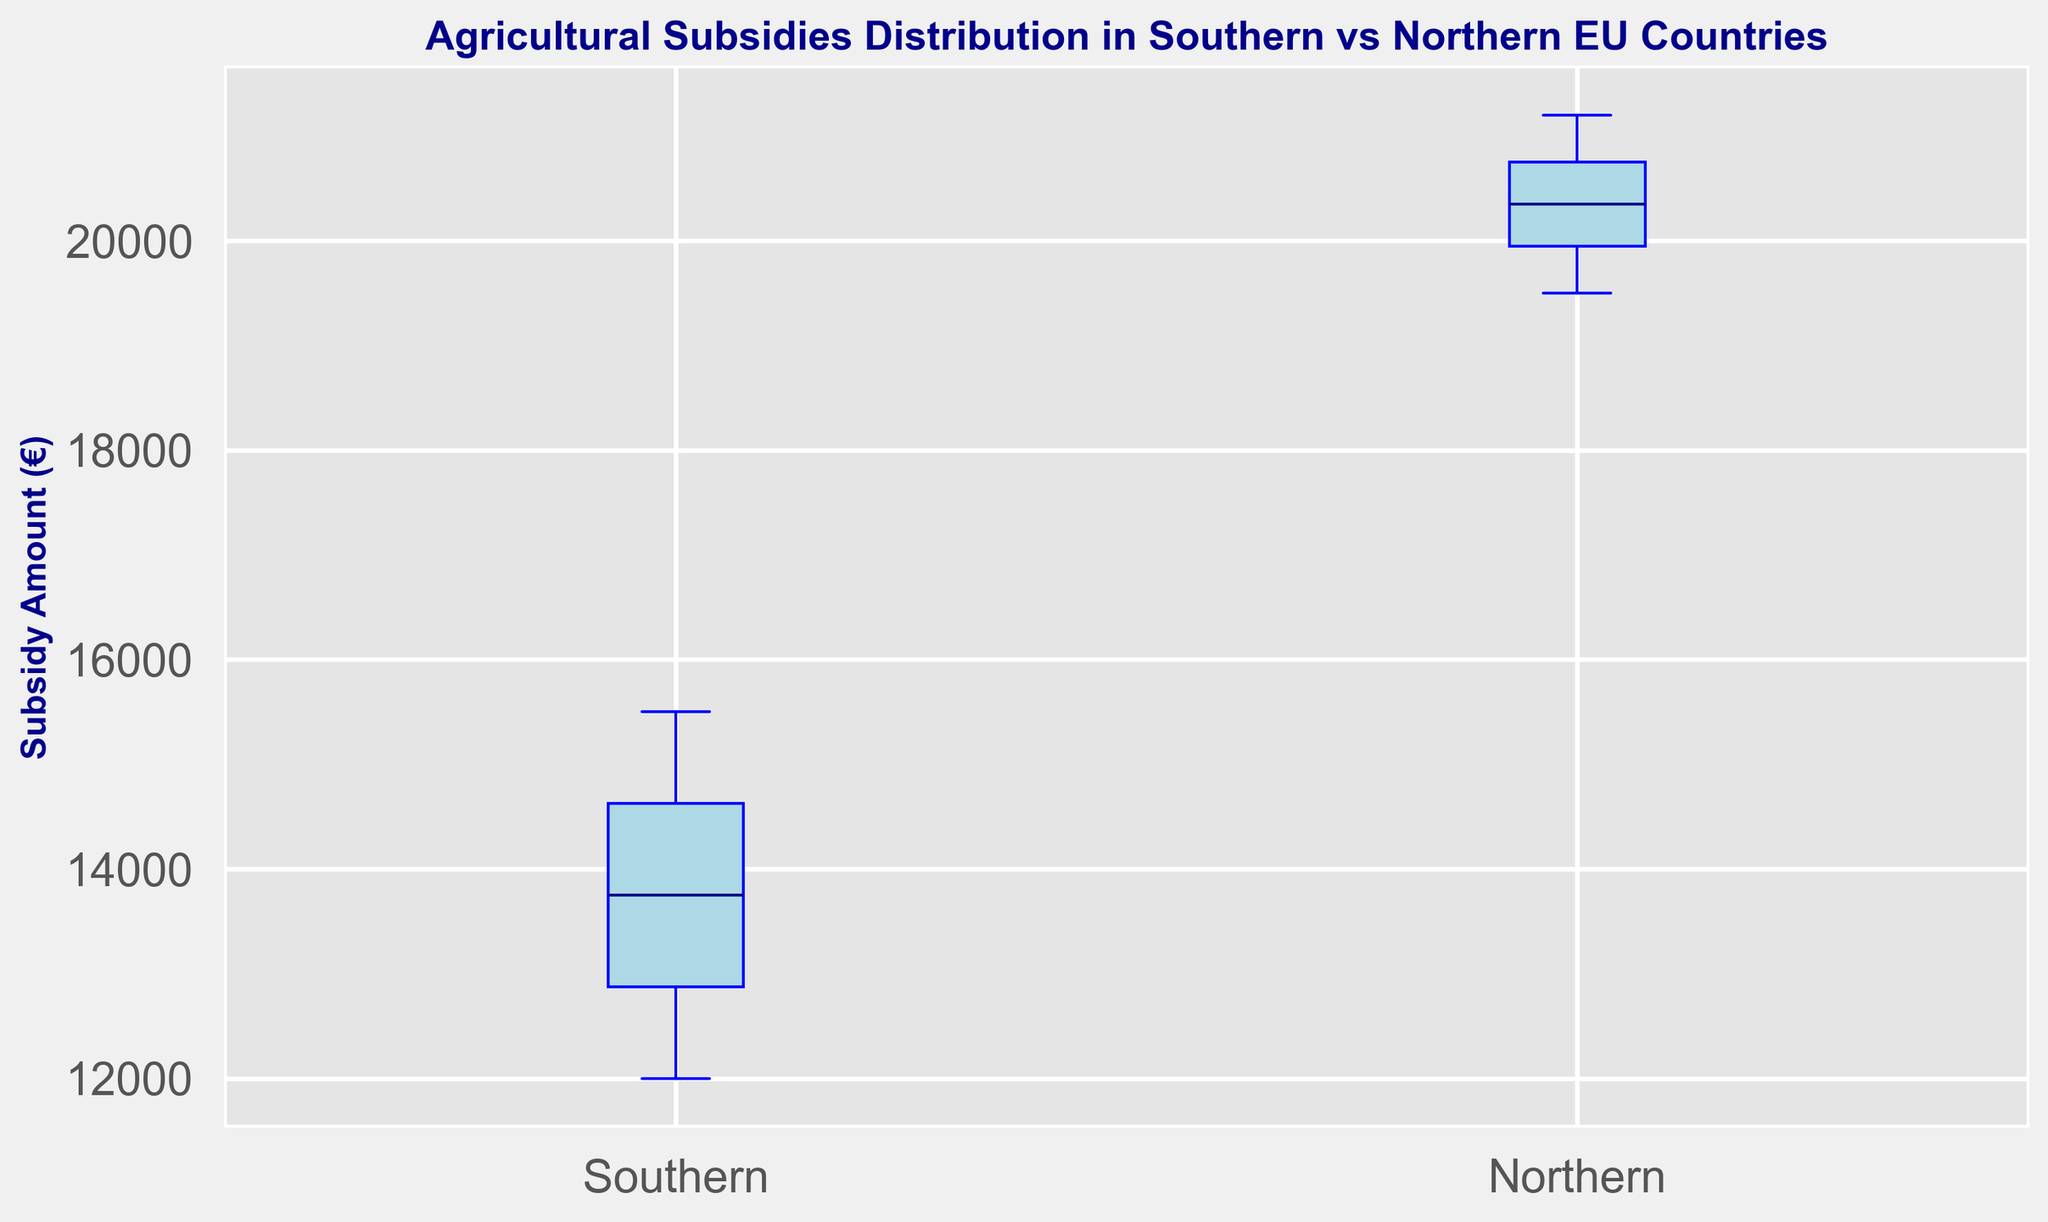How are the median subsidy amounts different between Southern and Northern EU countries? The median line in each boxplot represents the median subsidy amount. By comparing the positions of these lines, we can see that the median subsidy in Northern EU countries is higher than in Southern EU countries.
Answer: Northern EU countries have a higher median subsidy What is the range of subsidies in Southern EU countries compared to Northern EU countries? The range can be determined by looking at the distance between the bottom and top whiskers of each boxplot. The range for Southern EU countries is smaller than the range for Northern EU countries.
Answer: Northern EU countries have a larger range Do the Southern EU countries have any outliers in their subsidy distribution? Outliers are represented by data points that appear outside the whiskers of the boxplot, marked by small red circles. There are no outliers shown for Southern EU countries.
Answer: No Which region has a higher upper quartile (75th percentile) of subsidies? The upper quartile is represented by the top of the box in the boxplot. By comparing the tops of the boxes, Northern EU countries have a higher upper quartile than Southern EU countries.
Answer: Northern EU countries How does the interquartile range (IQR) of subsidies compare between Southern and Northern EU countries? The IQR is the distance between the top (75th percentile) and bottom (25th percentile) of the box. Northern EU countries have a larger IQR compared to Southern EU countries.
Answer: Northern EU countries have a larger IQR Are the subsidy amounts more consistent in Southern or Northern EU countries? Consistency in a boxplot can be inferred from the spread of the data points. A smaller spread indicates more consistency. Southern EU countries show a smaller spread, suggesting more consistent subsidy amounts.
Answer: Southern EU countries 